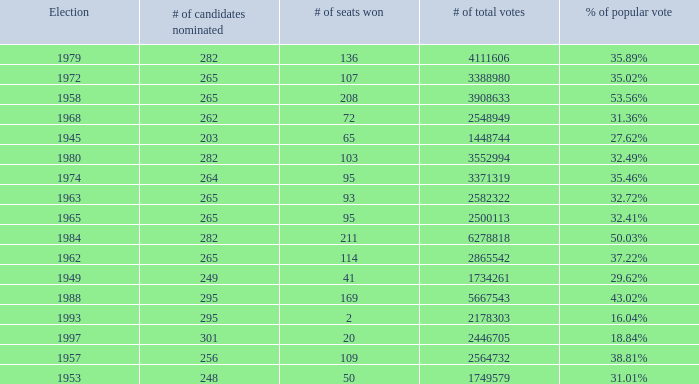What is the # of seats one for the election in 1974? 95.0. Could you parse the entire table? {'header': ['Election', '# of candidates nominated', '# of seats won', '# of total votes', '% of popular vote'], 'rows': [['1979', '282', '136', '4111606', '35.89%'], ['1972', '265', '107', '3388980', '35.02%'], ['1958', '265', '208', '3908633', '53.56%'], ['1968', '262', '72', '2548949', '31.36%'], ['1945', '203', '65', '1448744', '27.62%'], ['1980', '282', '103', '3552994', '32.49%'], ['1974', '264', '95', '3371319', '35.46%'], ['1963', '265', '93', '2582322', '32.72%'], ['1965', '265', '95', '2500113', '32.41%'], ['1984', '282', '211', '6278818', '50.03%'], ['1962', '265', '114', '2865542', '37.22%'], ['1949', '249', '41', '1734261', '29.62%'], ['1988', '295', '169', '5667543', '43.02%'], ['1993', '295', '2', '2178303', '16.04%'], ['1997', '301', '20', '2446705', '18.84%'], ['1957', '256', '109', '2564732', '38.81%'], ['1953', '248', '50', '1749579', '31.01%']]} 